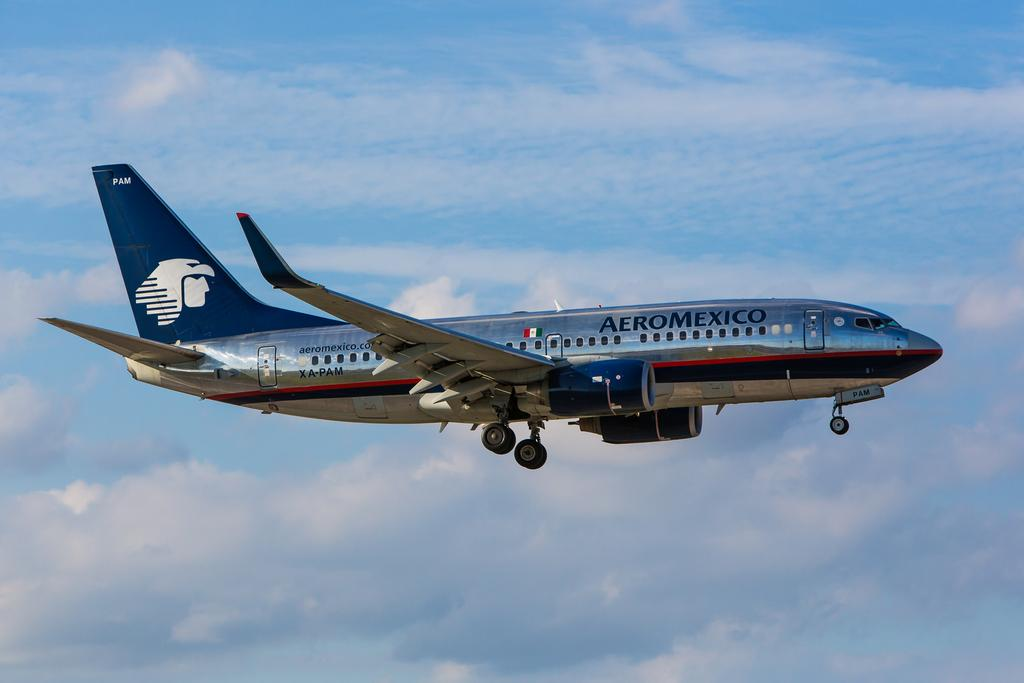What is the main subject of the image? The main subject of the image is an airplane. What is the airplane doing in the image? The airplane is flying. What can be seen in the background of the image? The sky is visible in the background of the image. What else is present in the sky? Clouds are present in the sky. How does the airplane express its feeling of excitement in the image? Airplanes do not have feelings, so they cannot express excitement in the image. 